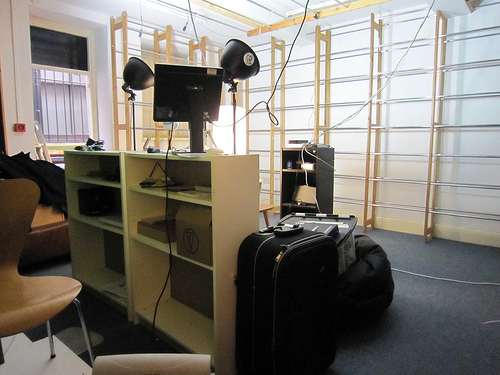<image>
Is there a window behind the cupboard? No. The window is not behind the cupboard. From this viewpoint, the window appears to be positioned elsewhere in the scene. 